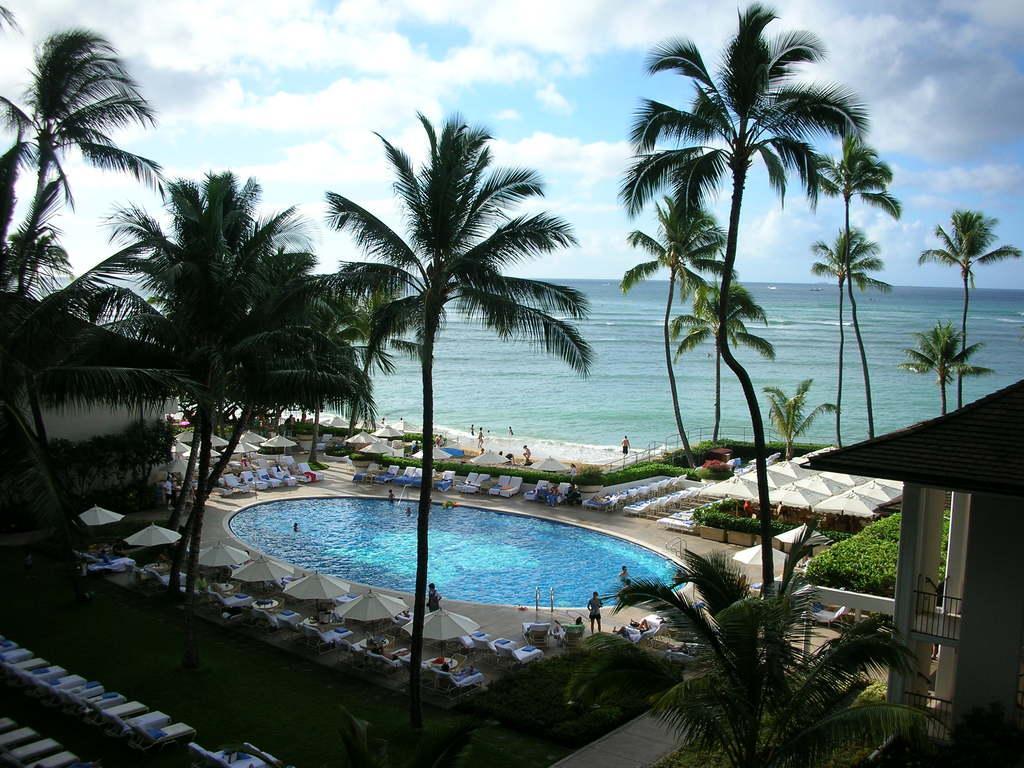Please provide a concise description of this image. In this picture I can observe a swimming pool. There are some people in the swimming pool. I can observe some chairs and trees in this picture. In the background there is an ocean and a sky. There are some clouds in the sky. 